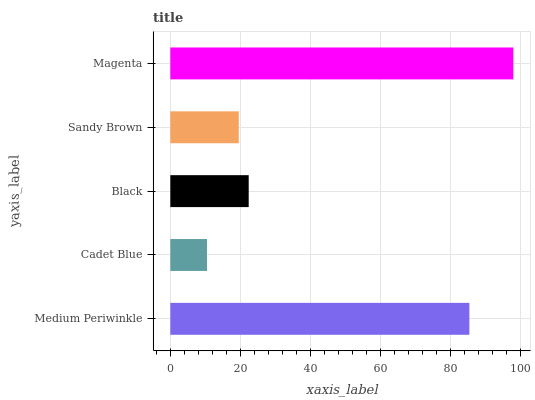Is Cadet Blue the minimum?
Answer yes or no. Yes. Is Magenta the maximum?
Answer yes or no. Yes. Is Black the minimum?
Answer yes or no. No. Is Black the maximum?
Answer yes or no. No. Is Black greater than Cadet Blue?
Answer yes or no. Yes. Is Cadet Blue less than Black?
Answer yes or no. Yes. Is Cadet Blue greater than Black?
Answer yes or no. No. Is Black less than Cadet Blue?
Answer yes or no. No. Is Black the high median?
Answer yes or no. Yes. Is Black the low median?
Answer yes or no. Yes. Is Sandy Brown the high median?
Answer yes or no. No. Is Cadet Blue the low median?
Answer yes or no. No. 